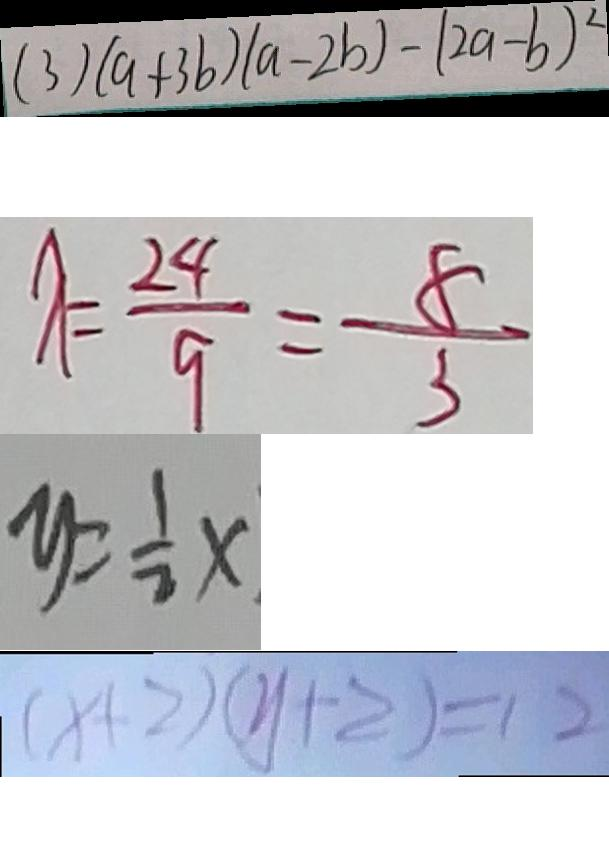<formula> <loc_0><loc_0><loc_500><loc_500>( 3 ) ( a + 3 b ) ( a - 2 b ) - ( 2 a - b ) ^ { 2 } 
 \lambda = \frac { 2 4 } { 9 } = \frac { 8 } { 3 } 
 y = \frac { 1 } { 2 } x 
 ( x + 2 ) ( y + 2 ) = 1 2</formula> 